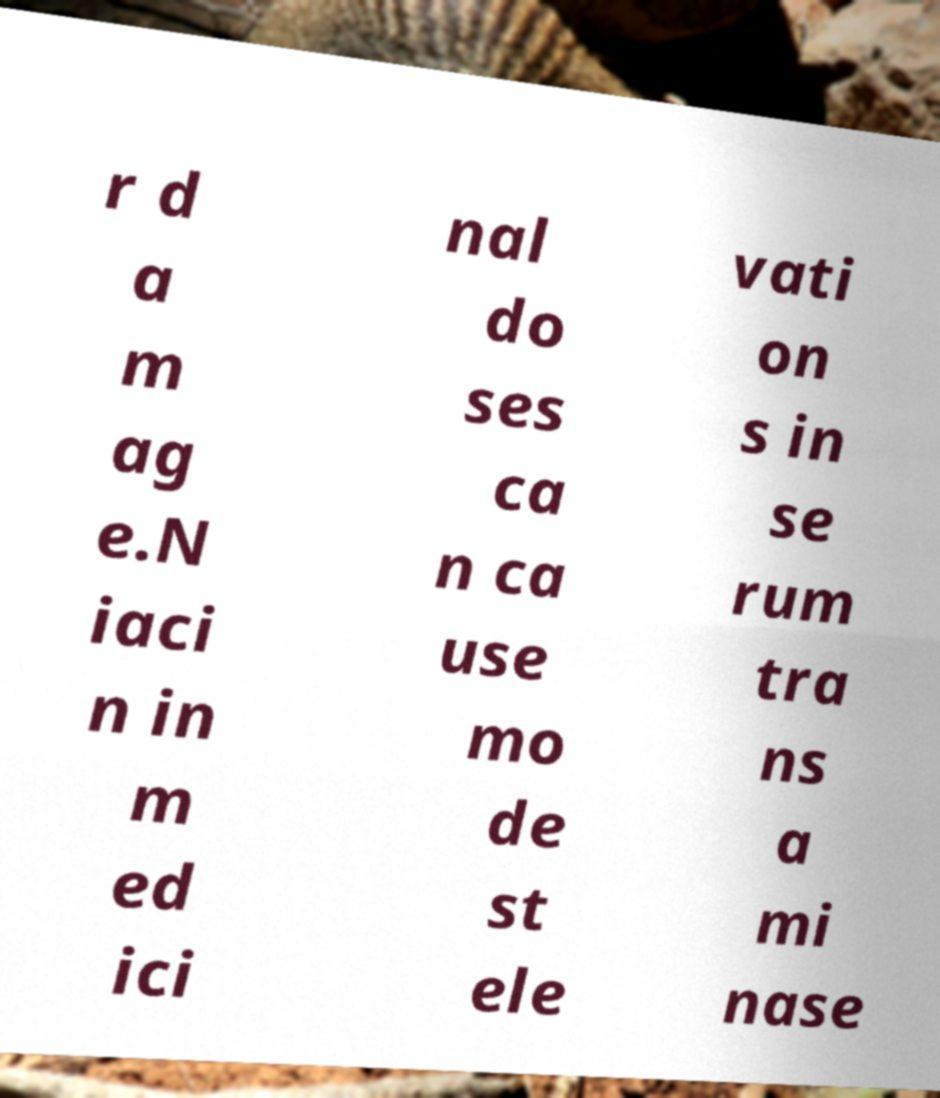Can you read and provide the text displayed in the image?This photo seems to have some interesting text. Can you extract and type it out for me? r d a m ag e.N iaci n in m ed ici nal do ses ca n ca use mo de st ele vati on s in se rum tra ns a mi nase 